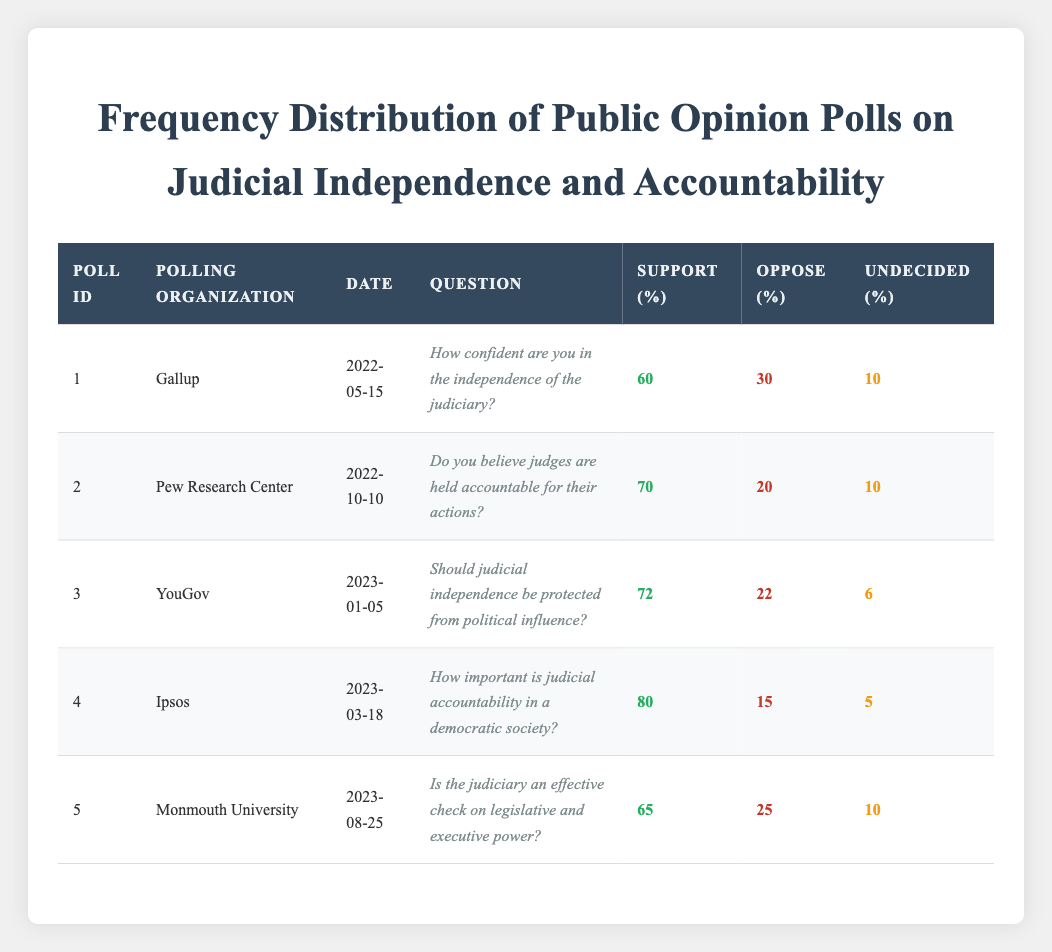What is the date of the poll conducted by Gallup? The table lists the polling organizations and their corresponding dates. Under Gallup, the date is stated as 2022-05-15.
Answer: 2022-05-15 Which polling organization recorded the highest support for judicial accountability? According to the table, Ipsos has the highest support percentage for judicial accountability at 80%, which is found under the respective support column.
Answer: Ipsos What is the average percentage of undecided responses across all polls? To calculate the average, we first sum the undecided percentages: (10 + 10 + 6 + 5 + 10) = 51. Then, divide this by the total number of polls, which is 5: 51/5 = 10.2.
Answer: 10.2 Is there a poll that shows more support for the independence of the judiciary than for accountability? By examining the support percentages, Gallup reports 60% for judiciary independence and Pew Research Center reports 70% for accountability. Since 60% is less than 70%, the answer is yes, Gallup shows more support for independence than Pew shows for accountability.
Answer: Yes Which poll indicates the lowest level of opposition to judicial effectiveness? The table shows that Monmouth University has the lowest opposition at 25%, compared to the other polls. This is verified by looking at the oppose column values.
Answer: 25 Do a majority of respondents believe that judges are held accountable for their actions? The table shows that Pew Research Center has 70% support for the question regarding judges being held accountable. Since this is more than 50%, a majority does believe so.
Answer: Yes What is the difference in support for judicial independence between YouGov and Gallup? Looking at the support percentages for independence, YouGov has 72% while Gallup has 60%. The difference is calculated as 72 - 60 = 12.
Answer: 12 What percentage of respondents were undecided in the poll conducted by Ipsos? The table shows that the Ipsos poll indicates 5% of respondents were undecided, as noted in the undecided column.
Answer: 5 What is the total percentage of support across all five polls? To find the total support, we sum up all support percentages: (60 + 70 + 72 + 80 + 65) = 347.
Answer: 347 